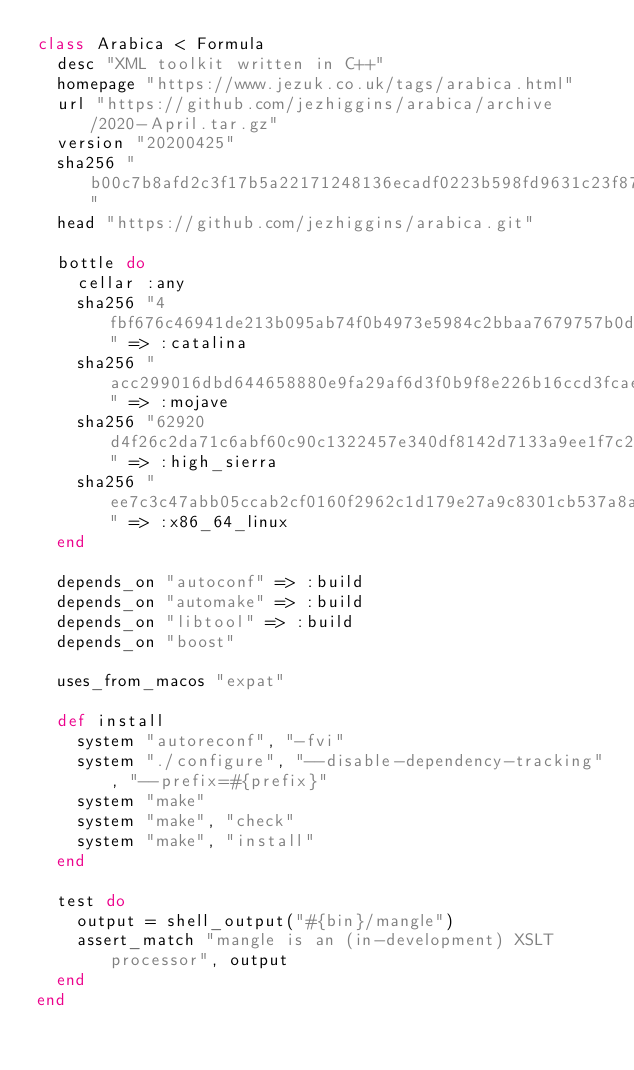Convert code to text. <code><loc_0><loc_0><loc_500><loc_500><_Ruby_>class Arabica < Formula
  desc "XML toolkit written in C++"
  homepage "https://www.jezuk.co.uk/tags/arabica.html"
  url "https://github.com/jezhiggins/arabica/archive/2020-April.tar.gz"
  version "20200425"
  sha256 "b00c7b8afd2c3f17b5a22171248136ecadf0223b598fd9631c23f875a5ce87fe"
  head "https://github.com/jezhiggins/arabica.git"

  bottle do
    cellar :any
    sha256 "4fbf676c46941de213b095ab74f0b4973e5984c2bbaa7679757b0db4b369480a" => :catalina
    sha256 "acc299016dbd644658880e9fa29af6d3f0b9f8e226b16ccd3fcaea8dae23febf" => :mojave
    sha256 "62920d4f26c2da71c6abf60c90c1322457e340df8142d7133a9ee1f7c2b46745" => :high_sierra
    sha256 "ee7c3c47abb05ccab2cf0160f2962c1d179e27a9c8301cb537a8a077a2f2cba5" => :x86_64_linux
  end

  depends_on "autoconf" => :build
  depends_on "automake" => :build
  depends_on "libtool" => :build
  depends_on "boost"

  uses_from_macos "expat"

  def install
    system "autoreconf", "-fvi"
    system "./configure", "--disable-dependency-tracking", "--prefix=#{prefix}"
    system "make"
    system "make", "check"
    system "make", "install"
  end

  test do
    output = shell_output("#{bin}/mangle")
    assert_match "mangle is an (in-development) XSLT processor", output
  end
end
</code> 